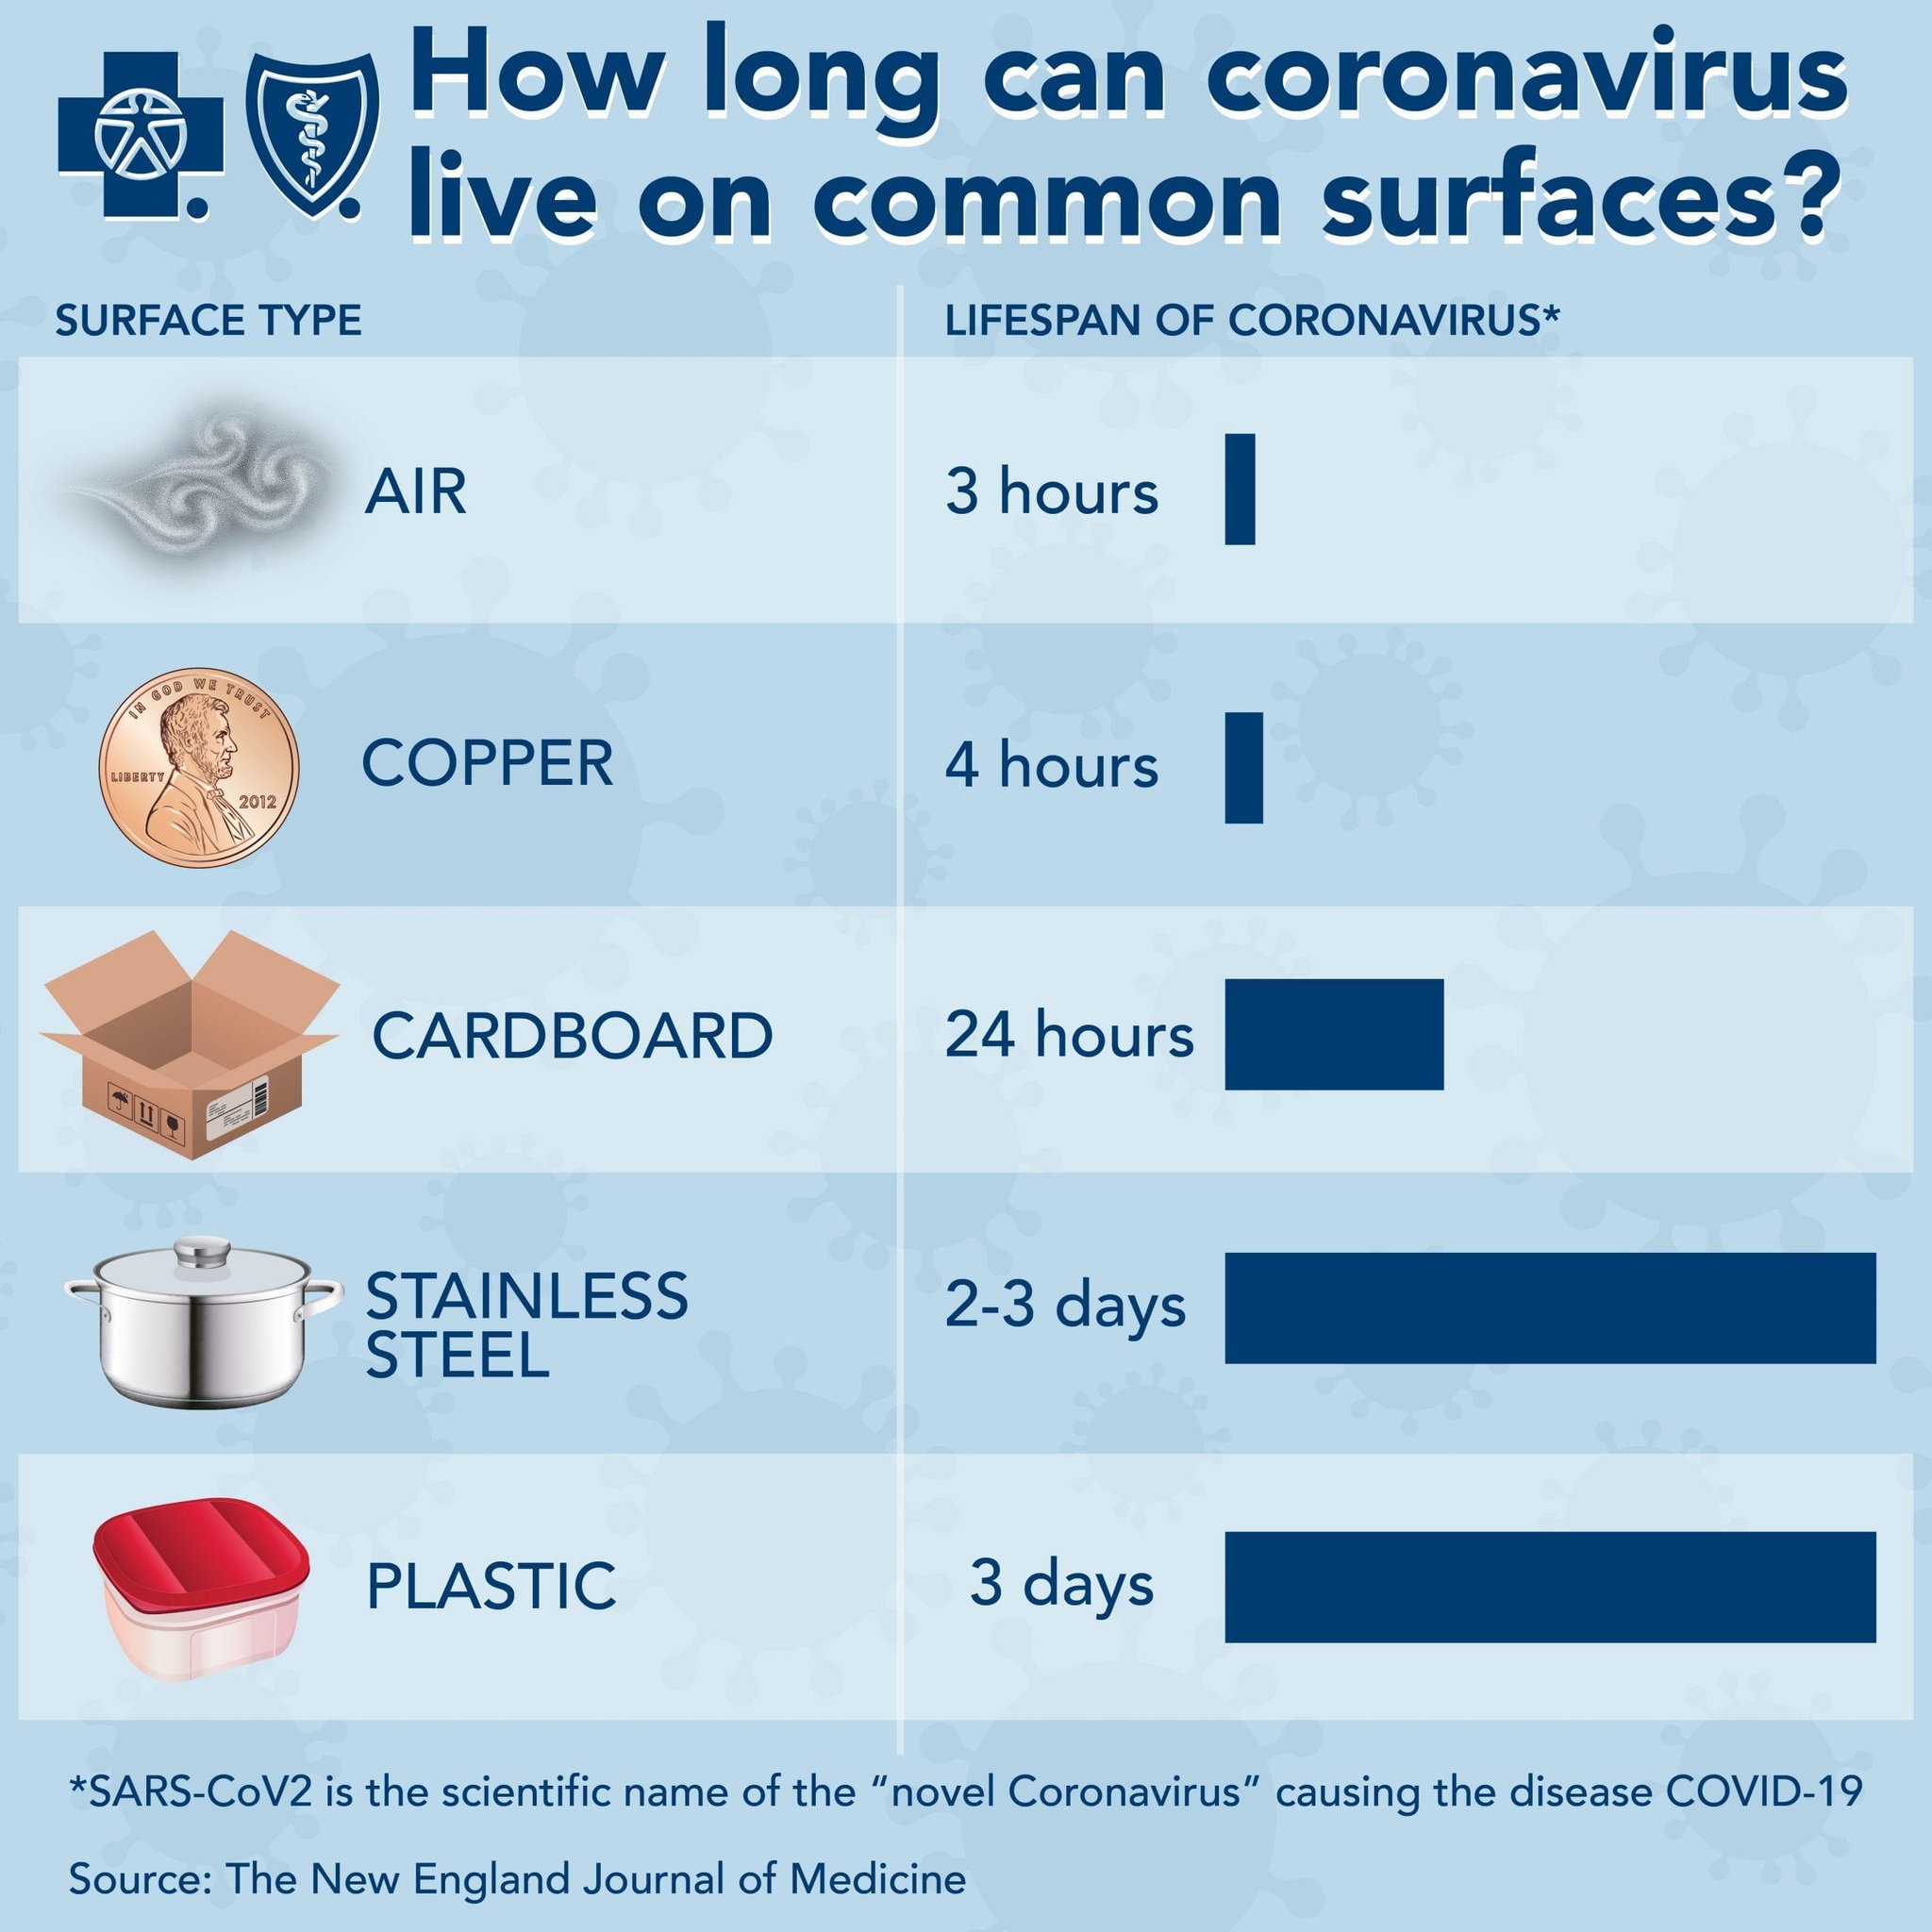List a handful of essential elements in this visual. The second shortest lifespan of a surface corona is observed in copper. Air has been found to be a surface where the coronavirus has a short lifespan. 